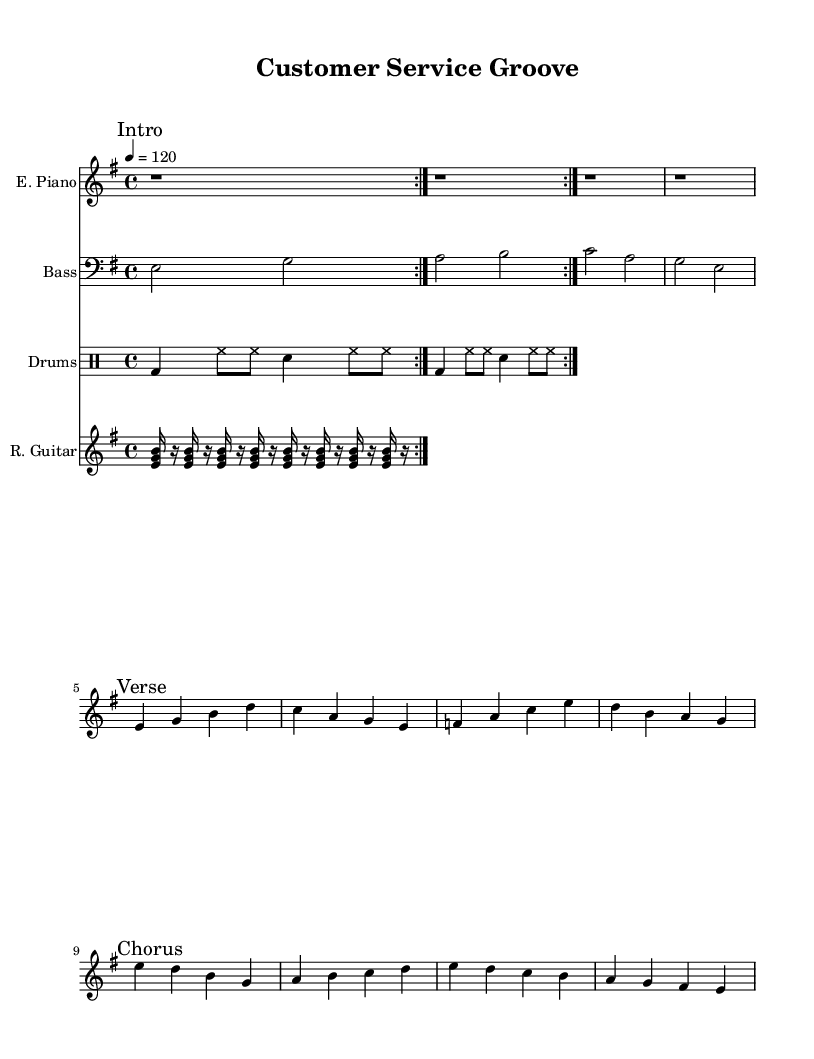What is the key signature of this music? The key signature indicates E minor, which is represented by a single sharp (F#) in the context of this piece.
Answer: E minor What is the time signature of this music? The time signature shown is 4/4, which means there are four beats in each measure and the quarter note gets one beat. This information is typically located at the beginning of the sheet music.
Answer: 4/4 What is the tempo marking? The tempo marking reads 4 = 120, which indicates that the quarter note should be played at a speed of 120 beats per minute. This is a standard way to indicate tempo in sheet music.
Answer: 120 How many measures are in the verse section? The verse section contains a total of four measures, which can be counted by looking at the notes between the "Verse" marking and the following break. Each grouping of notes corresponds to a measure.
Answer: 4 What instruments are included in this arrangement? This arrangement includes an Electric Piano, Bass, Drums, and Rhythm Guitar, as denoted by the instrument names above each staff in the score.
Answer: Electric Piano, Bass, Drums, Rhythm Guitar How many beats are in the drum pattern before repeating? The drum pattern is structured into measures that total to two repetitions of 8 beats, as indicated by the repeated volta marking, which means the pattern will repeat after this section.
Answer: 8 What type of musical style is this piece classified as? This piece is classified as Dance music, specifically inspired by funky disco elements, which can be inferred from the upbeat tempo and rhythmic patterns typical of dance tracks.
Answer: Dance 